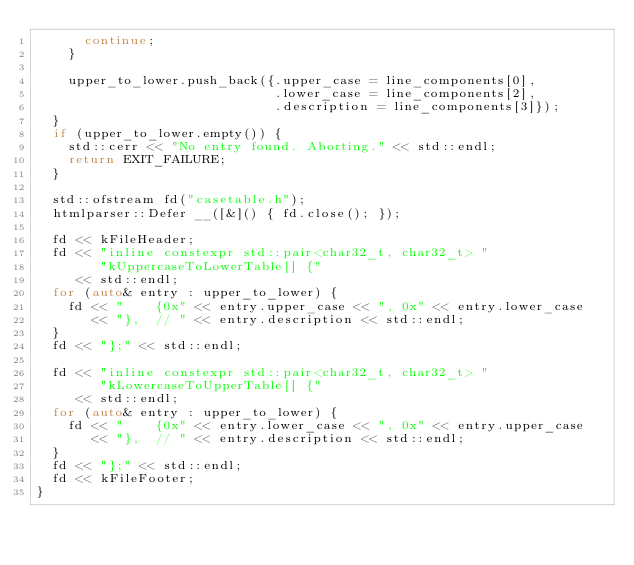Convert code to text. <code><loc_0><loc_0><loc_500><loc_500><_C++_>      continue;
    }

    upper_to_lower.push_back({.upper_case = line_components[0],
                              .lower_case = line_components[2],
                              .description = line_components[3]});
  }
  if (upper_to_lower.empty()) {
    std::cerr << "No entry found. Aborting." << std::endl;
    return EXIT_FAILURE;
  }

  std::ofstream fd("casetable.h");
  htmlparser::Defer __([&]() { fd.close(); });

  fd << kFileHeader;
  fd << "inline constexpr std::pair<char32_t, char32_t> "
        "kUppercaseToLowerTable[] {"
     << std::endl;
  for (auto& entry : upper_to_lower) {
    fd << "    {0x" << entry.upper_case << ", 0x" << entry.lower_case
       << "},  // " << entry.description << std::endl;
  }
  fd << "};" << std::endl;

  fd << "inline constexpr std::pair<char32_t, char32_t> "
        "kLowercaseToUpperTable[] {"
     << std::endl;
  for (auto& entry : upper_to_lower) {
    fd << "    {0x" << entry.lower_case << ", 0x" << entry.upper_case
       << "},  // " << entry.description << std::endl;
  }
  fd << "};" << std::endl;
  fd << kFileFooter;
}
</code> 